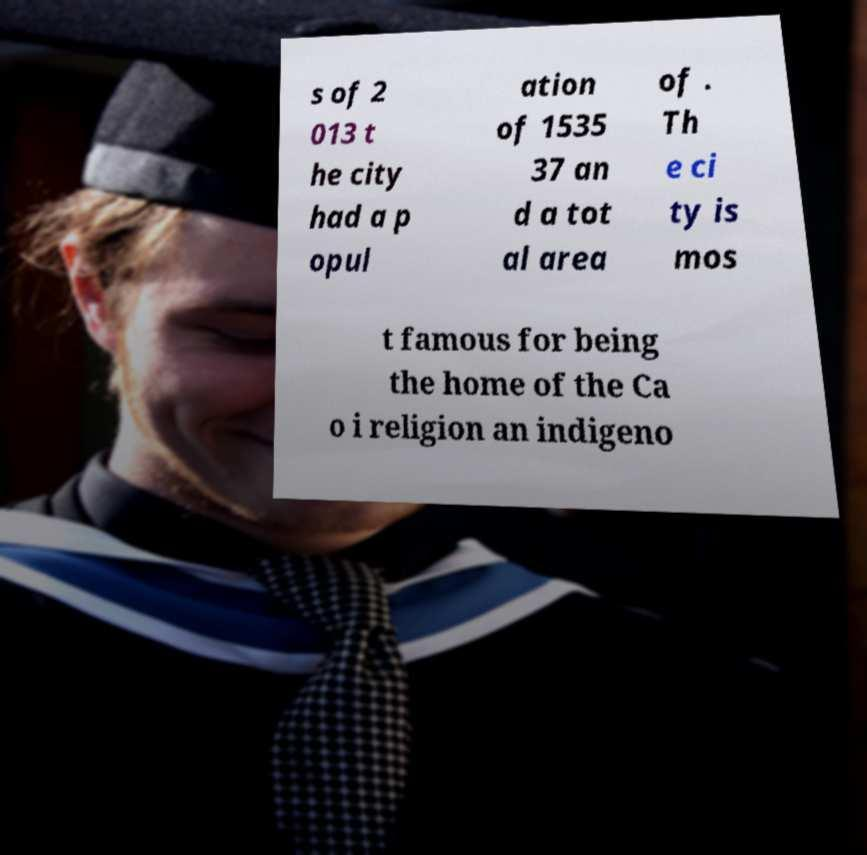Can you accurately transcribe the text from the provided image for me? s of 2 013 t he city had a p opul ation of 1535 37 an d a tot al area of . Th e ci ty is mos t famous for being the home of the Ca o i religion an indigeno 